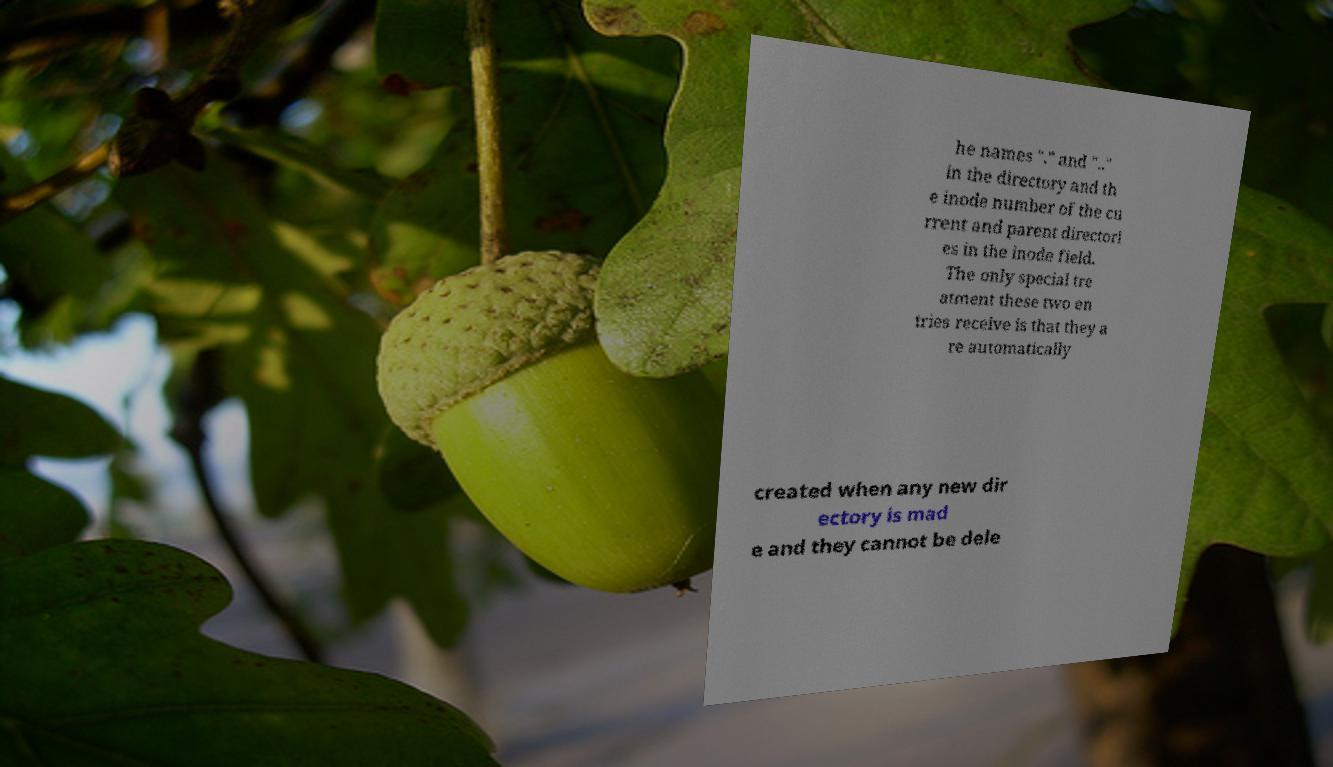There's text embedded in this image that I need extracted. Can you transcribe it verbatim? he names "." and ".." in the directory and th e inode number of the cu rrent and parent directori es in the inode field. The only special tre atment these two en tries receive is that they a re automatically created when any new dir ectory is mad e and they cannot be dele 